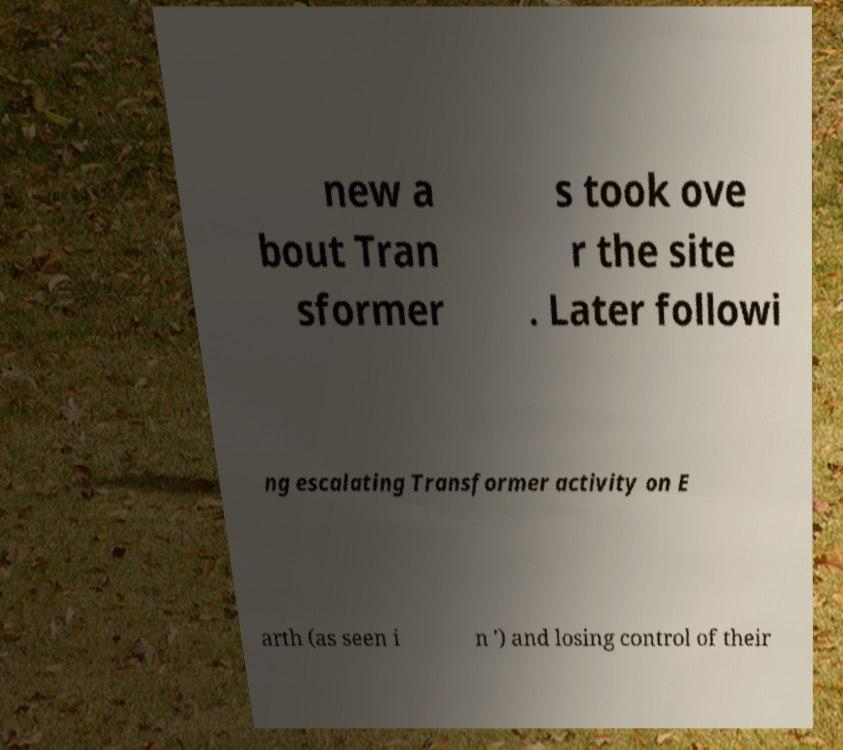Can you read and provide the text displayed in the image?This photo seems to have some interesting text. Can you extract and type it out for me? new a bout Tran sformer s took ove r the site . Later followi ng escalating Transformer activity on E arth (as seen i n ') and losing control of their 